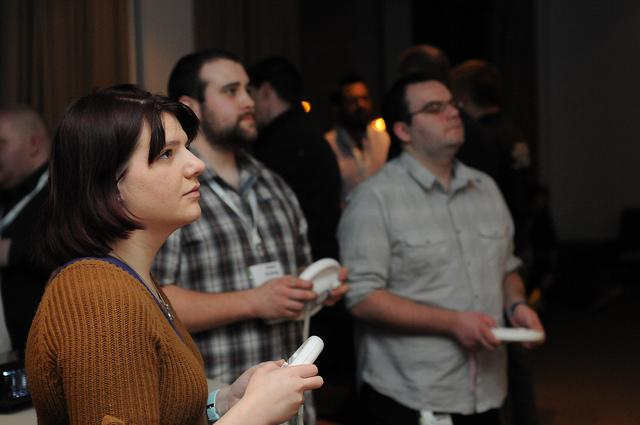What part of a car is symbolized in the objects they are holding? steering wheel 